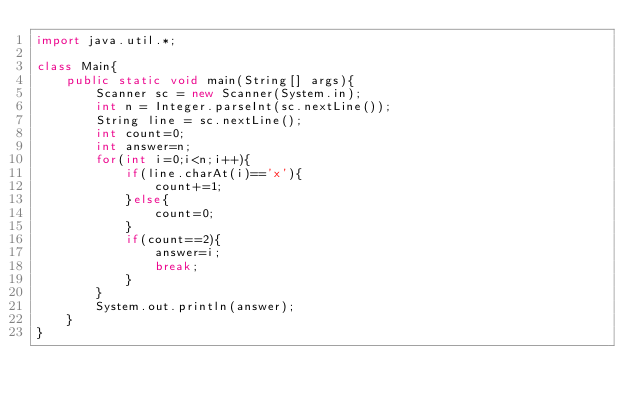Convert code to text. <code><loc_0><loc_0><loc_500><loc_500><_Java_>import java.util.*;

class Main{
	public static void main(String[] args){
		Scanner sc = new Scanner(System.in);
		int n = Integer.parseInt(sc.nextLine());
		String line = sc.nextLine();
		int count=0;
		int answer=n;
		for(int i=0;i<n;i++){
			if(line.charAt(i)=='x'){
				count+=1;
			}else{
				count=0;
			}
			if(count==2){
				answer=i;
				break;
			}
		}
		System.out.println(answer);
	}
}</code> 